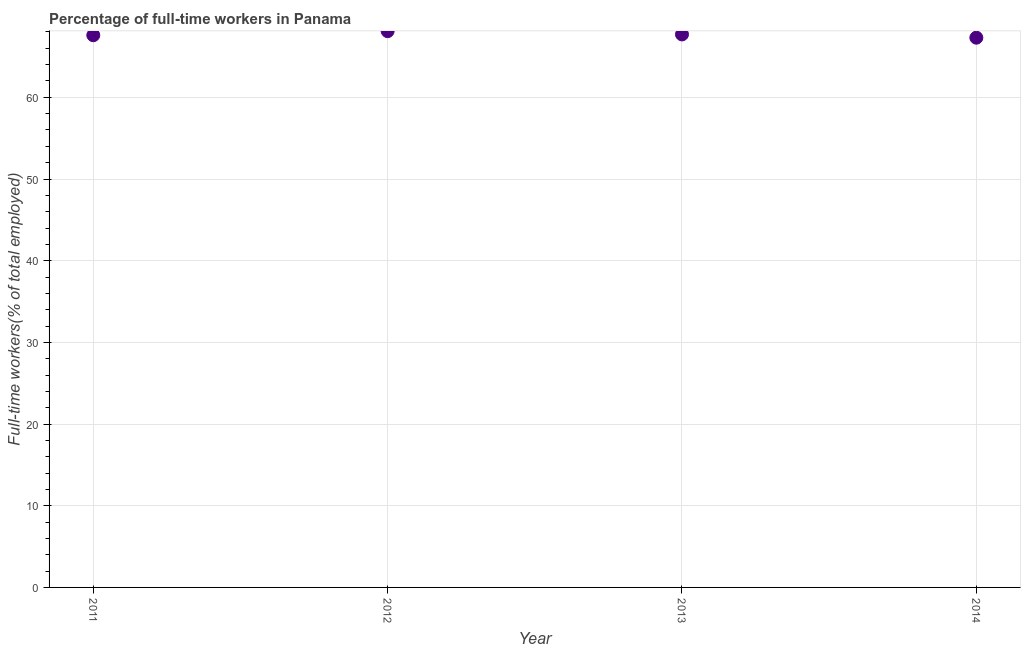What is the percentage of full-time workers in 2013?
Give a very brief answer. 67.7. Across all years, what is the maximum percentage of full-time workers?
Give a very brief answer. 68.1. Across all years, what is the minimum percentage of full-time workers?
Ensure brevity in your answer.  67.3. In which year was the percentage of full-time workers maximum?
Ensure brevity in your answer.  2012. In which year was the percentage of full-time workers minimum?
Provide a short and direct response. 2014. What is the sum of the percentage of full-time workers?
Offer a very short reply. 270.7. What is the difference between the percentage of full-time workers in 2012 and 2013?
Offer a terse response. 0.4. What is the average percentage of full-time workers per year?
Offer a terse response. 67.67. What is the median percentage of full-time workers?
Give a very brief answer. 67.65. Do a majority of the years between 2013 and 2014 (inclusive) have percentage of full-time workers greater than 6 %?
Give a very brief answer. Yes. What is the ratio of the percentage of full-time workers in 2012 to that in 2014?
Provide a succinct answer. 1.01. What is the difference between the highest and the second highest percentage of full-time workers?
Offer a terse response. 0.4. What is the difference between the highest and the lowest percentage of full-time workers?
Ensure brevity in your answer.  0.8. Does the percentage of full-time workers monotonically increase over the years?
Offer a very short reply. No. Are the values on the major ticks of Y-axis written in scientific E-notation?
Give a very brief answer. No. Does the graph contain any zero values?
Make the answer very short. No. Does the graph contain grids?
Ensure brevity in your answer.  Yes. What is the title of the graph?
Keep it short and to the point. Percentage of full-time workers in Panama. What is the label or title of the Y-axis?
Offer a very short reply. Full-time workers(% of total employed). What is the Full-time workers(% of total employed) in 2011?
Your response must be concise. 67.6. What is the Full-time workers(% of total employed) in 2012?
Ensure brevity in your answer.  68.1. What is the Full-time workers(% of total employed) in 2013?
Offer a terse response. 67.7. What is the Full-time workers(% of total employed) in 2014?
Ensure brevity in your answer.  67.3. What is the difference between the Full-time workers(% of total employed) in 2013 and 2014?
Make the answer very short. 0.4. What is the ratio of the Full-time workers(% of total employed) in 2011 to that in 2013?
Provide a succinct answer. 1. What is the ratio of the Full-time workers(% of total employed) in 2011 to that in 2014?
Offer a terse response. 1. What is the ratio of the Full-time workers(% of total employed) in 2012 to that in 2013?
Ensure brevity in your answer.  1.01. What is the ratio of the Full-time workers(% of total employed) in 2013 to that in 2014?
Keep it short and to the point. 1.01. 